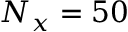Convert formula to latex. <formula><loc_0><loc_0><loc_500><loc_500>N _ { x } = 5 0</formula> 